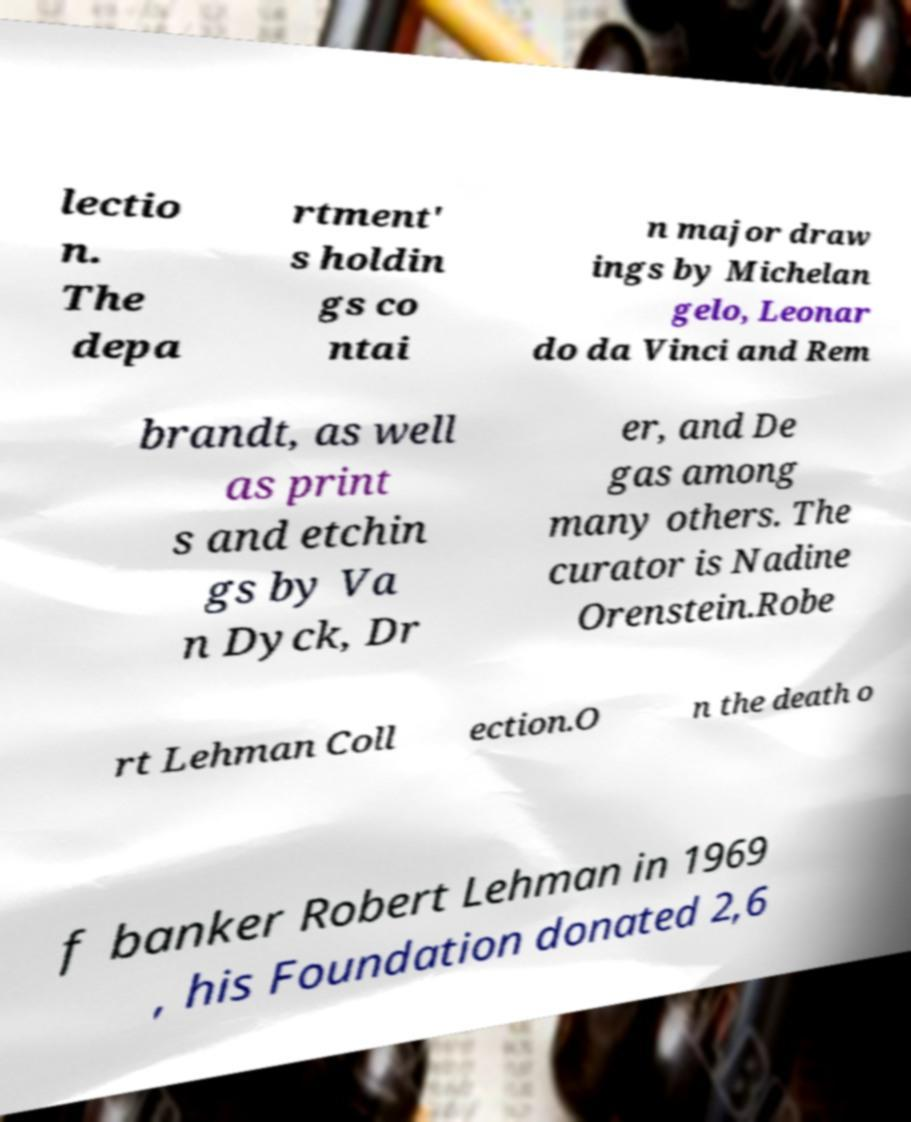There's text embedded in this image that I need extracted. Can you transcribe it verbatim? lectio n. The depa rtment' s holdin gs co ntai n major draw ings by Michelan gelo, Leonar do da Vinci and Rem brandt, as well as print s and etchin gs by Va n Dyck, Dr er, and De gas among many others. The curator is Nadine Orenstein.Robe rt Lehman Coll ection.O n the death o f banker Robert Lehman in 1969 , his Foundation donated 2,6 